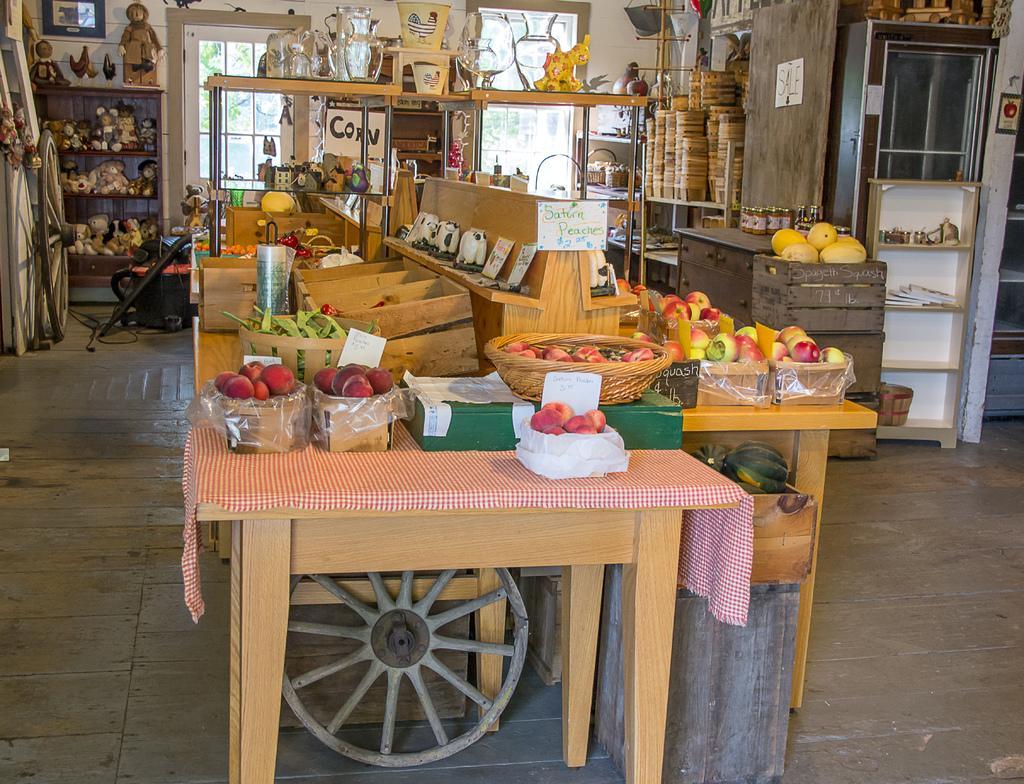In one or two sentences, can you explain what this image depicts? In this picture we can see apples,basket, mangoes, cupboard, tablecloth. And to the left corner there is a wheel and some toys. There is a window and also a vacuum cleaner. On the table there are some jars. 